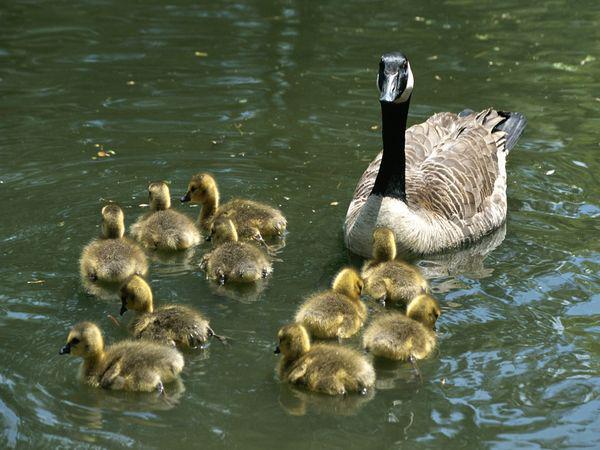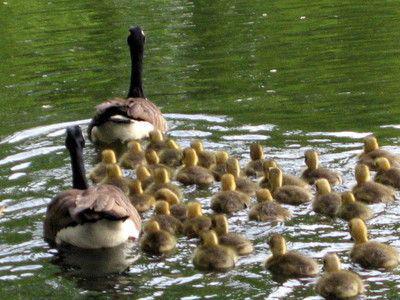The first image is the image on the left, the second image is the image on the right. For the images displayed, is the sentence "The ducks are swimming in at least one of the images." factually correct? Answer yes or no. Yes. The first image is the image on the left, the second image is the image on the right. Examine the images to the left and right. Is the description "two parents are swimming with their baby geese." accurate? Answer yes or no. Yes. 